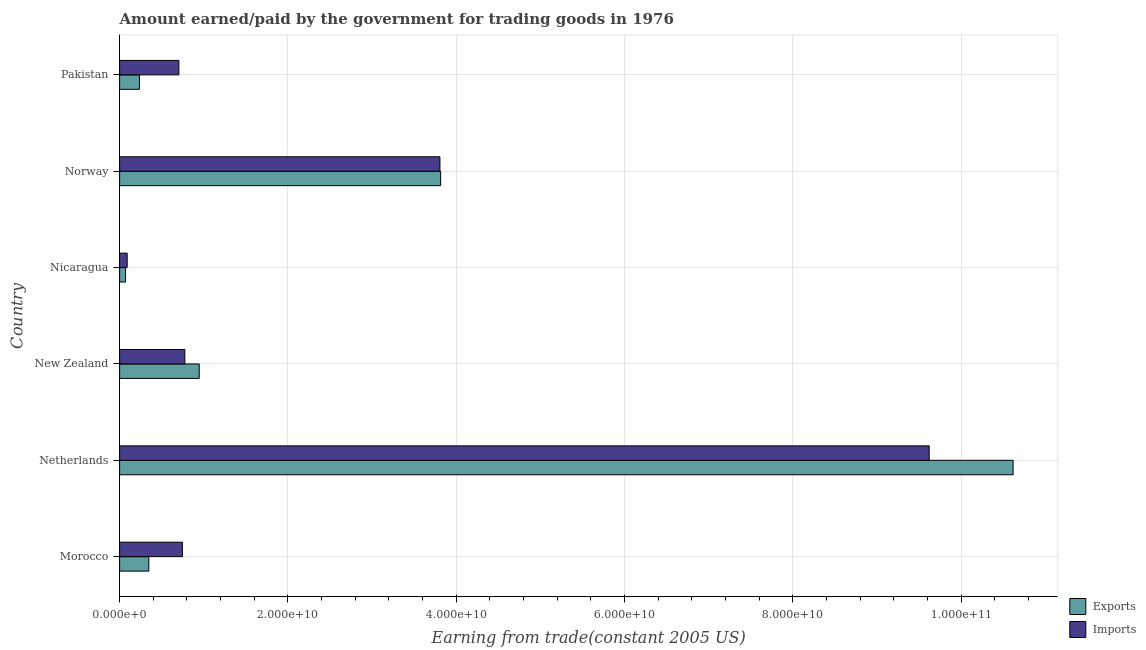How many different coloured bars are there?
Make the answer very short. 2. Are the number of bars per tick equal to the number of legend labels?
Give a very brief answer. Yes. What is the label of the 4th group of bars from the top?
Your response must be concise. New Zealand. In how many cases, is the number of bars for a given country not equal to the number of legend labels?
Give a very brief answer. 0. What is the amount earned from exports in New Zealand?
Ensure brevity in your answer.  9.46e+09. Across all countries, what is the maximum amount earned from exports?
Make the answer very short. 1.06e+11. Across all countries, what is the minimum amount paid for imports?
Your answer should be very brief. 9.00e+08. In which country was the amount earned from exports minimum?
Keep it short and to the point. Nicaragua. What is the total amount earned from exports in the graph?
Keep it short and to the point. 1.60e+11. What is the difference between the amount earned from exports in Morocco and that in Netherlands?
Provide a short and direct response. -1.03e+11. What is the difference between the amount paid for imports in Norway and the amount earned from exports in Pakistan?
Offer a terse response. 3.57e+1. What is the average amount paid for imports per country?
Offer a very short reply. 2.62e+1. What is the difference between the amount paid for imports and amount earned from exports in Morocco?
Your answer should be compact. 3.99e+09. What is the ratio of the amount earned from exports in Morocco to that in Netherlands?
Ensure brevity in your answer.  0.03. Is the difference between the amount earned from exports in Morocco and Netherlands greater than the difference between the amount paid for imports in Morocco and Netherlands?
Offer a very short reply. No. What is the difference between the highest and the second highest amount paid for imports?
Provide a short and direct response. 5.81e+1. What is the difference between the highest and the lowest amount paid for imports?
Give a very brief answer. 9.53e+1. What does the 1st bar from the top in Norway represents?
Give a very brief answer. Imports. What does the 1st bar from the bottom in Pakistan represents?
Keep it short and to the point. Exports. Are all the bars in the graph horizontal?
Your response must be concise. Yes. How many countries are there in the graph?
Offer a terse response. 6. Are the values on the major ticks of X-axis written in scientific E-notation?
Provide a short and direct response. Yes. Does the graph contain any zero values?
Your answer should be very brief. No. Does the graph contain grids?
Give a very brief answer. Yes. What is the title of the graph?
Keep it short and to the point. Amount earned/paid by the government for trading goods in 1976. Does "Net savings(excluding particulate emission damage)" appear as one of the legend labels in the graph?
Keep it short and to the point. No. What is the label or title of the X-axis?
Give a very brief answer. Earning from trade(constant 2005 US). What is the label or title of the Y-axis?
Offer a very short reply. Country. What is the Earning from trade(constant 2005 US) in Exports in Morocco?
Offer a very short reply. 3.47e+09. What is the Earning from trade(constant 2005 US) of Imports in Morocco?
Keep it short and to the point. 7.46e+09. What is the Earning from trade(constant 2005 US) of Exports in Netherlands?
Offer a terse response. 1.06e+11. What is the Earning from trade(constant 2005 US) of Imports in Netherlands?
Provide a succinct answer. 9.62e+1. What is the Earning from trade(constant 2005 US) of Exports in New Zealand?
Offer a terse response. 9.46e+09. What is the Earning from trade(constant 2005 US) of Imports in New Zealand?
Provide a succinct answer. 7.75e+09. What is the Earning from trade(constant 2005 US) of Exports in Nicaragua?
Offer a terse response. 7.07e+08. What is the Earning from trade(constant 2005 US) of Imports in Nicaragua?
Your response must be concise. 9.00e+08. What is the Earning from trade(constant 2005 US) in Exports in Norway?
Provide a succinct answer. 3.81e+1. What is the Earning from trade(constant 2005 US) in Imports in Norway?
Your answer should be very brief. 3.81e+1. What is the Earning from trade(constant 2005 US) in Exports in Pakistan?
Provide a short and direct response. 2.36e+09. What is the Earning from trade(constant 2005 US) in Imports in Pakistan?
Your answer should be compact. 7.04e+09. Across all countries, what is the maximum Earning from trade(constant 2005 US) of Exports?
Ensure brevity in your answer.  1.06e+11. Across all countries, what is the maximum Earning from trade(constant 2005 US) in Imports?
Your answer should be very brief. 9.62e+1. Across all countries, what is the minimum Earning from trade(constant 2005 US) in Exports?
Your answer should be compact. 7.07e+08. Across all countries, what is the minimum Earning from trade(constant 2005 US) in Imports?
Your answer should be compact. 9.00e+08. What is the total Earning from trade(constant 2005 US) in Exports in the graph?
Your answer should be compact. 1.60e+11. What is the total Earning from trade(constant 2005 US) in Imports in the graph?
Offer a very short reply. 1.57e+11. What is the difference between the Earning from trade(constant 2005 US) in Exports in Morocco and that in Netherlands?
Your answer should be compact. -1.03e+11. What is the difference between the Earning from trade(constant 2005 US) in Imports in Morocco and that in Netherlands?
Offer a terse response. -8.87e+1. What is the difference between the Earning from trade(constant 2005 US) of Exports in Morocco and that in New Zealand?
Offer a very short reply. -5.99e+09. What is the difference between the Earning from trade(constant 2005 US) in Imports in Morocco and that in New Zealand?
Offer a terse response. -2.91e+08. What is the difference between the Earning from trade(constant 2005 US) in Exports in Morocco and that in Nicaragua?
Give a very brief answer. 2.77e+09. What is the difference between the Earning from trade(constant 2005 US) in Imports in Morocco and that in Nicaragua?
Make the answer very short. 6.56e+09. What is the difference between the Earning from trade(constant 2005 US) of Exports in Morocco and that in Norway?
Keep it short and to the point. -3.47e+1. What is the difference between the Earning from trade(constant 2005 US) of Imports in Morocco and that in Norway?
Provide a short and direct response. -3.06e+1. What is the difference between the Earning from trade(constant 2005 US) in Exports in Morocco and that in Pakistan?
Ensure brevity in your answer.  1.12e+09. What is the difference between the Earning from trade(constant 2005 US) in Imports in Morocco and that in Pakistan?
Keep it short and to the point. 4.20e+08. What is the difference between the Earning from trade(constant 2005 US) in Exports in Netherlands and that in New Zealand?
Provide a short and direct response. 9.67e+1. What is the difference between the Earning from trade(constant 2005 US) of Imports in Netherlands and that in New Zealand?
Provide a short and direct response. 8.84e+1. What is the difference between the Earning from trade(constant 2005 US) of Exports in Netherlands and that in Nicaragua?
Offer a very short reply. 1.05e+11. What is the difference between the Earning from trade(constant 2005 US) in Imports in Netherlands and that in Nicaragua?
Your answer should be very brief. 9.53e+1. What is the difference between the Earning from trade(constant 2005 US) in Exports in Netherlands and that in Norway?
Your response must be concise. 6.80e+1. What is the difference between the Earning from trade(constant 2005 US) of Imports in Netherlands and that in Norway?
Give a very brief answer. 5.81e+1. What is the difference between the Earning from trade(constant 2005 US) of Exports in Netherlands and that in Pakistan?
Your answer should be compact. 1.04e+11. What is the difference between the Earning from trade(constant 2005 US) of Imports in Netherlands and that in Pakistan?
Offer a terse response. 8.91e+1. What is the difference between the Earning from trade(constant 2005 US) in Exports in New Zealand and that in Nicaragua?
Offer a terse response. 8.75e+09. What is the difference between the Earning from trade(constant 2005 US) in Imports in New Zealand and that in Nicaragua?
Your response must be concise. 6.85e+09. What is the difference between the Earning from trade(constant 2005 US) in Exports in New Zealand and that in Norway?
Offer a very short reply. -2.87e+1. What is the difference between the Earning from trade(constant 2005 US) of Imports in New Zealand and that in Norway?
Give a very brief answer. -3.03e+1. What is the difference between the Earning from trade(constant 2005 US) in Exports in New Zealand and that in Pakistan?
Offer a very short reply. 7.10e+09. What is the difference between the Earning from trade(constant 2005 US) of Imports in New Zealand and that in Pakistan?
Provide a short and direct response. 7.11e+08. What is the difference between the Earning from trade(constant 2005 US) in Exports in Nicaragua and that in Norway?
Your answer should be very brief. -3.74e+1. What is the difference between the Earning from trade(constant 2005 US) in Imports in Nicaragua and that in Norway?
Offer a terse response. -3.72e+1. What is the difference between the Earning from trade(constant 2005 US) in Exports in Nicaragua and that in Pakistan?
Offer a very short reply. -1.65e+09. What is the difference between the Earning from trade(constant 2005 US) in Imports in Nicaragua and that in Pakistan?
Your answer should be compact. -6.14e+09. What is the difference between the Earning from trade(constant 2005 US) of Exports in Norway and that in Pakistan?
Provide a short and direct response. 3.58e+1. What is the difference between the Earning from trade(constant 2005 US) in Imports in Norway and that in Pakistan?
Keep it short and to the point. 3.10e+1. What is the difference between the Earning from trade(constant 2005 US) of Exports in Morocco and the Earning from trade(constant 2005 US) of Imports in Netherlands?
Your answer should be compact. -9.27e+1. What is the difference between the Earning from trade(constant 2005 US) of Exports in Morocco and the Earning from trade(constant 2005 US) of Imports in New Zealand?
Offer a very short reply. -4.28e+09. What is the difference between the Earning from trade(constant 2005 US) in Exports in Morocco and the Earning from trade(constant 2005 US) in Imports in Nicaragua?
Provide a short and direct response. 2.57e+09. What is the difference between the Earning from trade(constant 2005 US) in Exports in Morocco and the Earning from trade(constant 2005 US) in Imports in Norway?
Provide a short and direct response. -3.46e+1. What is the difference between the Earning from trade(constant 2005 US) in Exports in Morocco and the Earning from trade(constant 2005 US) in Imports in Pakistan?
Your answer should be very brief. -3.57e+09. What is the difference between the Earning from trade(constant 2005 US) in Exports in Netherlands and the Earning from trade(constant 2005 US) in Imports in New Zealand?
Provide a short and direct response. 9.84e+1. What is the difference between the Earning from trade(constant 2005 US) in Exports in Netherlands and the Earning from trade(constant 2005 US) in Imports in Nicaragua?
Your answer should be compact. 1.05e+11. What is the difference between the Earning from trade(constant 2005 US) of Exports in Netherlands and the Earning from trade(constant 2005 US) of Imports in Norway?
Your response must be concise. 6.81e+1. What is the difference between the Earning from trade(constant 2005 US) of Exports in Netherlands and the Earning from trade(constant 2005 US) of Imports in Pakistan?
Your response must be concise. 9.91e+1. What is the difference between the Earning from trade(constant 2005 US) of Exports in New Zealand and the Earning from trade(constant 2005 US) of Imports in Nicaragua?
Provide a succinct answer. 8.56e+09. What is the difference between the Earning from trade(constant 2005 US) of Exports in New Zealand and the Earning from trade(constant 2005 US) of Imports in Norway?
Offer a terse response. -2.86e+1. What is the difference between the Earning from trade(constant 2005 US) in Exports in New Zealand and the Earning from trade(constant 2005 US) in Imports in Pakistan?
Provide a short and direct response. 2.42e+09. What is the difference between the Earning from trade(constant 2005 US) of Exports in Nicaragua and the Earning from trade(constant 2005 US) of Imports in Norway?
Offer a terse response. -3.74e+1. What is the difference between the Earning from trade(constant 2005 US) in Exports in Nicaragua and the Earning from trade(constant 2005 US) in Imports in Pakistan?
Give a very brief answer. -6.33e+09. What is the difference between the Earning from trade(constant 2005 US) in Exports in Norway and the Earning from trade(constant 2005 US) in Imports in Pakistan?
Your response must be concise. 3.11e+1. What is the average Earning from trade(constant 2005 US) of Exports per country?
Keep it short and to the point. 2.67e+1. What is the average Earning from trade(constant 2005 US) of Imports per country?
Give a very brief answer. 2.62e+1. What is the difference between the Earning from trade(constant 2005 US) in Exports and Earning from trade(constant 2005 US) in Imports in Morocco?
Make the answer very short. -3.99e+09. What is the difference between the Earning from trade(constant 2005 US) in Exports and Earning from trade(constant 2005 US) in Imports in Netherlands?
Ensure brevity in your answer.  9.97e+09. What is the difference between the Earning from trade(constant 2005 US) of Exports and Earning from trade(constant 2005 US) of Imports in New Zealand?
Keep it short and to the point. 1.71e+09. What is the difference between the Earning from trade(constant 2005 US) in Exports and Earning from trade(constant 2005 US) in Imports in Nicaragua?
Offer a very short reply. -1.92e+08. What is the difference between the Earning from trade(constant 2005 US) in Exports and Earning from trade(constant 2005 US) in Imports in Norway?
Offer a terse response. 8.51e+07. What is the difference between the Earning from trade(constant 2005 US) of Exports and Earning from trade(constant 2005 US) of Imports in Pakistan?
Your response must be concise. -4.68e+09. What is the ratio of the Earning from trade(constant 2005 US) in Exports in Morocco to that in Netherlands?
Keep it short and to the point. 0.03. What is the ratio of the Earning from trade(constant 2005 US) in Imports in Morocco to that in Netherlands?
Offer a very short reply. 0.08. What is the ratio of the Earning from trade(constant 2005 US) of Exports in Morocco to that in New Zealand?
Provide a short and direct response. 0.37. What is the ratio of the Earning from trade(constant 2005 US) in Imports in Morocco to that in New Zealand?
Keep it short and to the point. 0.96. What is the ratio of the Earning from trade(constant 2005 US) in Exports in Morocco to that in Nicaragua?
Give a very brief answer. 4.91. What is the ratio of the Earning from trade(constant 2005 US) in Imports in Morocco to that in Nicaragua?
Offer a very short reply. 8.29. What is the ratio of the Earning from trade(constant 2005 US) of Exports in Morocco to that in Norway?
Make the answer very short. 0.09. What is the ratio of the Earning from trade(constant 2005 US) in Imports in Morocco to that in Norway?
Your answer should be very brief. 0.2. What is the ratio of the Earning from trade(constant 2005 US) in Exports in Morocco to that in Pakistan?
Make the answer very short. 1.47. What is the ratio of the Earning from trade(constant 2005 US) in Imports in Morocco to that in Pakistan?
Offer a terse response. 1.06. What is the ratio of the Earning from trade(constant 2005 US) of Exports in Netherlands to that in New Zealand?
Your answer should be compact. 11.22. What is the ratio of the Earning from trade(constant 2005 US) in Imports in Netherlands to that in New Zealand?
Keep it short and to the point. 12.41. What is the ratio of the Earning from trade(constant 2005 US) of Exports in Netherlands to that in Nicaragua?
Ensure brevity in your answer.  150.08. What is the ratio of the Earning from trade(constant 2005 US) of Imports in Netherlands to that in Nicaragua?
Ensure brevity in your answer.  106.9. What is the ratio of the Earning from trade(constant 2005 US) of Exports in Netherlands to that in Norway?
Offer a very short reply. 2.78. What is the ratio of the Earning from trade(constant 2005 US) in Imports in Netherlands to that in Norway?
Provide a short and direct response. 2.53. What is the ratio of the Earning from trade(constant 2005 US) in Exports in Netherlands to that in Pakistan?
Provide a succinct answer. 45.05. What is the ratio of the Earning from trade(constant 2005 US) in Imports in Netherlands to that in Pakistan?
Offer a terse response. 13.66. What is the ratio of the Earning from trade(constant 2005 US) of Exports in New Zealand to that in Nicaragua?
Give a very brief answer. 13.38. What is the ratio of the Earning from trade(constant 2005 US) in Imports in New Zealand to that in Nicaragua?
Keep it short and to the point. 8.61. What is the ratio of the Earning from trade(constant 2005 US) in Exports in New Zealand to that in Norway?
Keep it short and to the point. 0.25. What is the ratio of the Earning from trade(constant 2005 US) of Imports in New Zealand to that in Norway?
Make the answer very short. 0.2. What is the ratio of the Earning from trade(constant 2005 US) in Exports in New Zealand to that in Pakistan?
Your answer should be compact. 4.01. What is the ratio of the Earning from trade(constant 2005 US) in Imports in New Zealand to that in Pakistan?
Offer a very short reply. 1.1. What is the ratio of the Earning from trade(constant 2005 US) of Exports in Nicaragua to that in Norway?
Make the answer very short. 0.02. What is the ratio of the Earning from trade(constant 2005 US) in Imports in Nicaragua to that in Norway?
Keep it short and to the point. 0.02. What is the ratio of the Earning from trade(constant 2005 US) in Exports in Nicaragua to that in Pakistan?
Offer a very short reply. 0.3. What is the ratio of the Earning from trade(constant 2005 US) in Imports in Nicaragua to that in Pakistan?
Give a very brief answer. 0.13. What is the ratio of the Earning from trade(constant 2005 US) of Exports in Norway to that in Pakistan?
Provide a short and direct response. 16.19. What is the ratio of the Earning from trade(constant 2005 US) in Imports in Norway to that in Pakistan?
Provide a short and direct response. 5.41. What is the difference between the highest and the second highest Earning from trade(constant 2005 US) in Exports?
Keep it short and to the point. 6.80e+1. What is the difference between the highest and the second highest Earning from trade(constant 2005 US) in Imports?
Provide a succinct answer. 5.81e+1. What is the difference between the highest and the lowest Earning from trade(constant 2005 US) in Exports?
Offer a terse response. 1.05e+11. What is the difference between the highest and the lowest Earning from trade(constant 2005 US) of Imports?
Your answer should be very brief. 9.53e+1. 